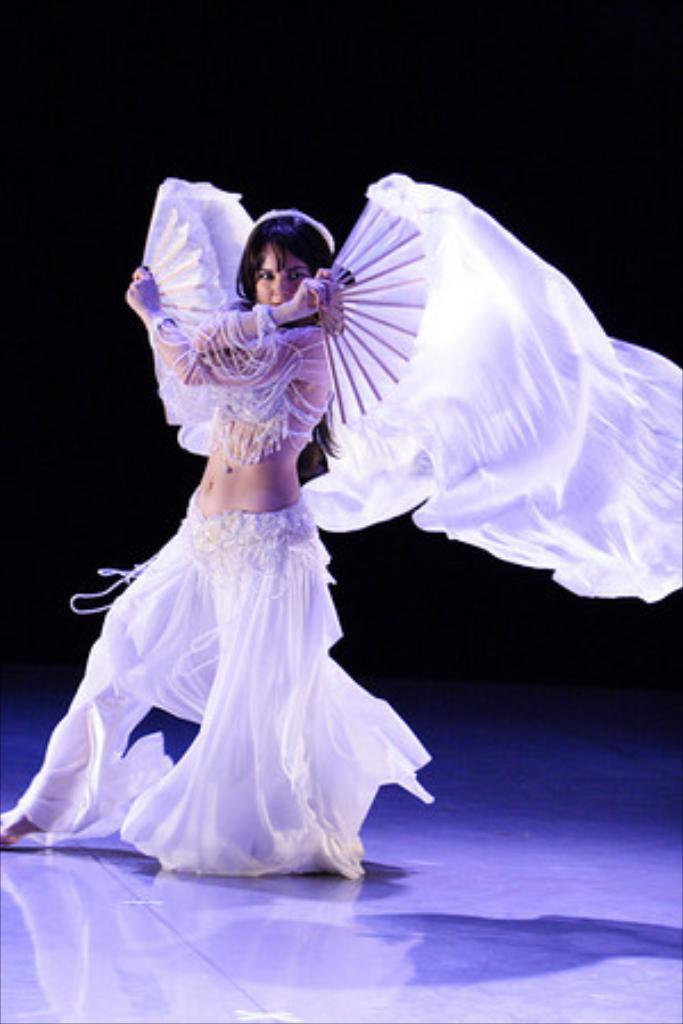Who is the main subject in the image? There is a lady in the center of the image. What is the lady doing in the image? The lady is dancing in the image. What is the lady holding in the image? The lady is holding an object in the image. What can be seen at the bottom of the image? There is a floor visible at the bottom of the image. What invention is the lady using to breathe in the image? There is no invention or breathing apparatus visible in the image. What type of milk is being poured in the image? There is no milk or pouring action visible in the image. 